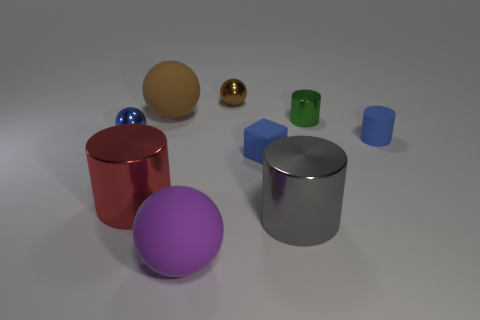Is the size of the red cylinder the same as the brown rubber sphere? While it's difficult to ascertain the exact dimensions from this angle, the red cylinder appears to be larger in height than the diameter of the brown rubber sphere, making them different in size. 